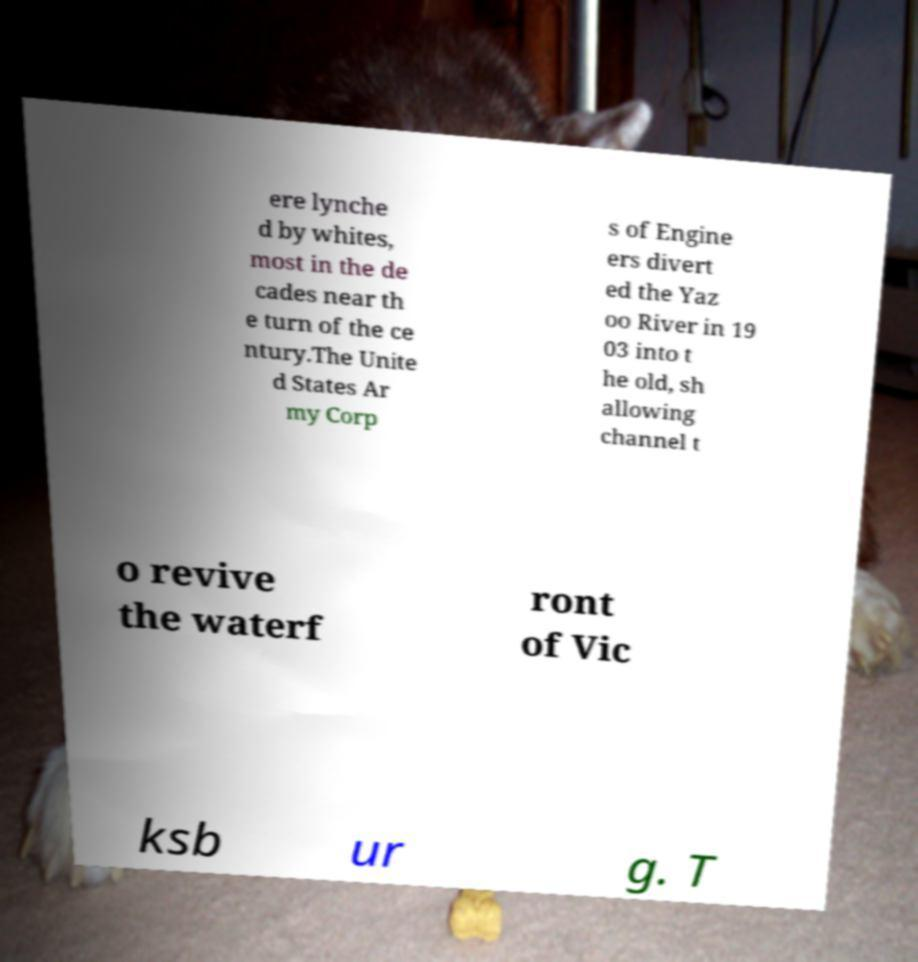Could you extract and type out the text from this image? ere lynche d by whites, most in the de cades near th e turn of the ce ntury.The Unite d States Ar my Corp s of Engine ers divert ed the Yaz oo River in 19 03 into t he old, sh allowing channel t o revive the waterf ront of Vic ksb ur g. T 